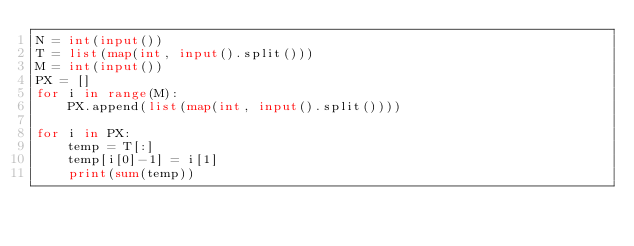<code> <loc_0><loc_0><loc_500><loc_500><_Python_>N = int(input())
T = list(map(int, input().split()))
M = int(input())
PX = []
for i in range(M):
    PX.append(list(map(int, input().split())))

for i in PX:
    temp = T[:]
    temp[i[0]-1] = i[1]
    print(sum(temp))
</code> 